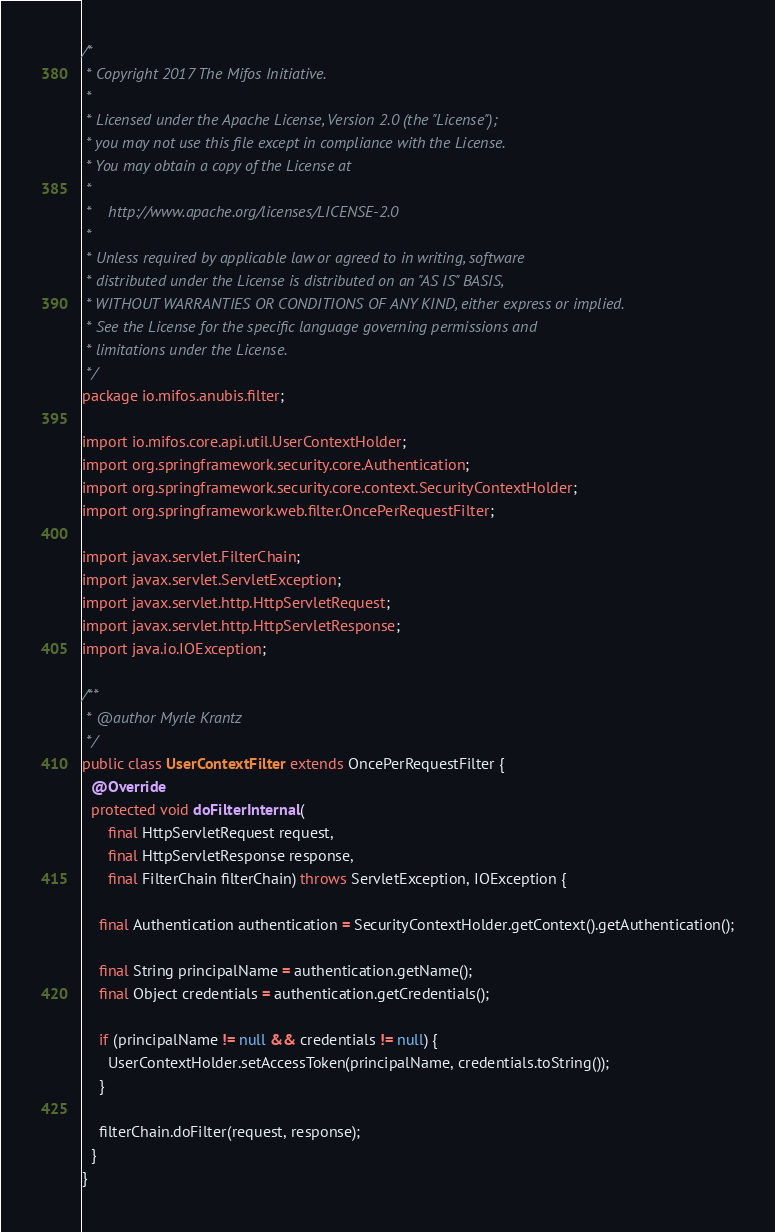Convert code to text. <code><loc_0><loc_0><loc_500><loc_500><_Java_>/*
 * Copyright 2017 The Mifos Initiative.
 *
 * Licensed under the Apache License, Version 2.0 (the "License");
 * you may not use this file except in compliance with the License.
 * You may obtain a copy of the License at
 *
 *    http://www.apache.org/licenses/LICENSE-2.0
 *
 * Unless required by applicable law or agreed to in writing, software
 * distributed under the License is distributed on an "AS IS" BASIS,
 * WITHOUT WARRANTIES OR CONDITIONS OF ANY KIND, either express or implied.
 * See the License for the specific language governing permissions and
 * limitations under the License.
 */
package io.mifos.anubis.filter;

import io.mifos.core.api.util.UserContextHolder;
import org.springframework.security.core.Authentication;
import org.springframework.security.core.context.SecurityContextHolder;
import org.springframework.web.filter.OncePerRequestFilter;

import javax.servlet.FilterChain;
import javax.servlet.ServletException;
import javax.servlet.http.HttpServletRequest;
import javax.servlet.http.HttpServletResponse;
import java.io.IOException;

/**
 * @author Myrle Krantz
 */
public class UserContextFilter extends OncePerRequestFilter {
  @Override
  protected void doFilterInternal(
      final HttpServletRequest request,
      final HttpServletResponse response,
      final FilterChain filterChain) throws ServletException, IOException {

    final Authentication authentication = SecurityContextHolder.getContext().getAuthentication();

    final String principalName = authentication.getName();
    final Object credentials = authentication.getCredentials();

    if (principalName != null && credentials != null) {
      UserContextHolder.setAccessToken(principalName, credentials.toString());
    }

    filterChain.doFilter(request, response);
  }
}
</code> 